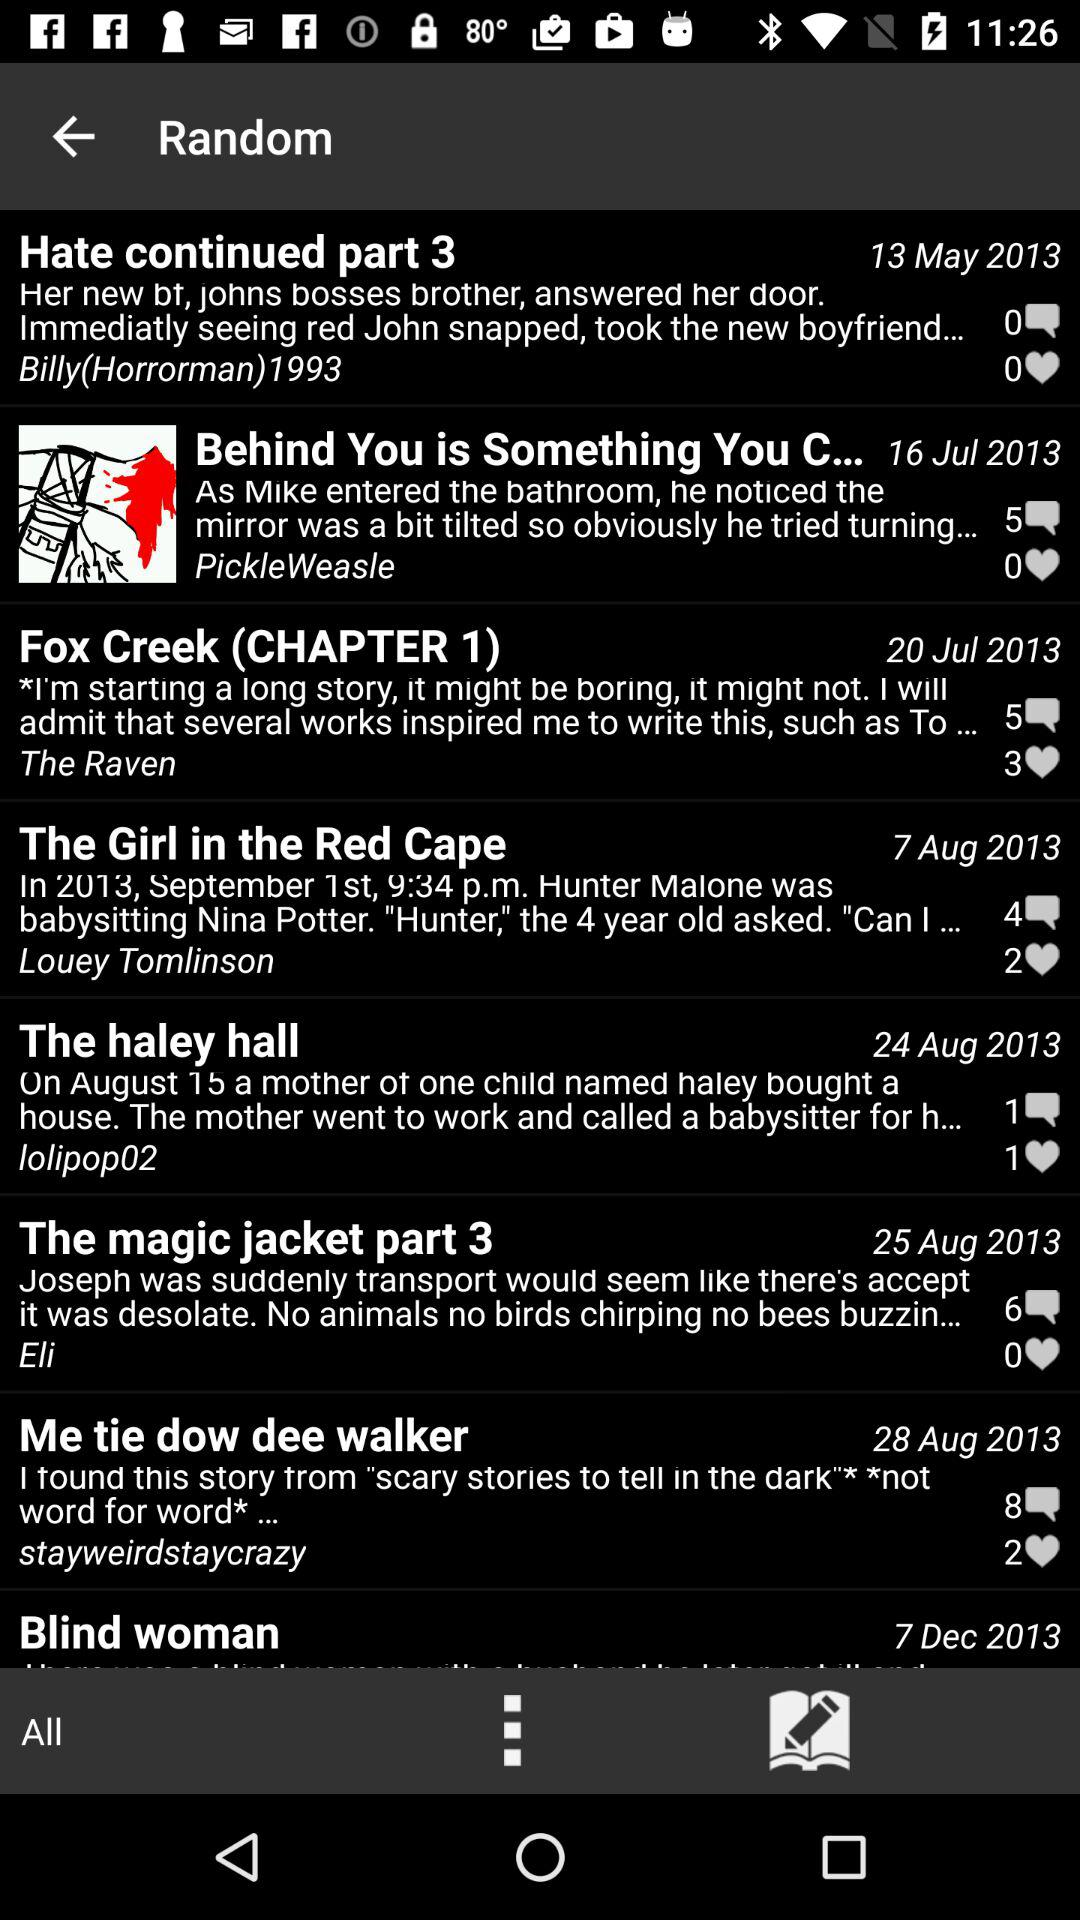How many likes are there of "Fox Creek"? There are 3 likes of "Fox Creek". 